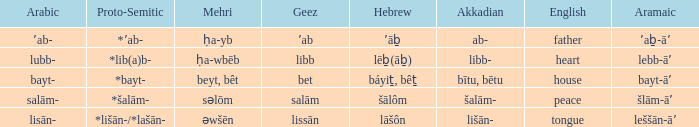If the geez is libb, what is the akkadian? Libb-. Would you be able to parse every entry in this table? {'header': ['Arabic', 'Proto-Semitic', 'Mehri', 'Geez', 'Hebrew', 'Akkadian', 'English', 'Aramaic'], 'rows': [['ʼab-', '*ʼab-', 'ḥa-yb', 'ʼab', 'ʼāḇ', 'ab-', 'father', 'ʼaḇ-āʼ'], ['lubb-', '*lib(a)b-', 'ḥa-wbēb', 'libb', 'lēḇ(āḇ)', 'libb-', 'heart', 'lebb-āʼ'], ['bayt-', '*bayt-', 'beyt, bêt', 'bet', 'báyiṯ, bêṯ', 'bītu, bētu', 'house', 'bayt-āʼ'], ['salām-', '*šalām-', 'səlōm', 'salām', 'šālôm', 'šalām-', 'peace', 'šlām-āʼ'], ['lisān-', '*lišān-/*lašān-', 'əwšēn', 'lissān', 'lāšôn', 'lišān-', 'tongue', 'leššān-āʼ']]} 